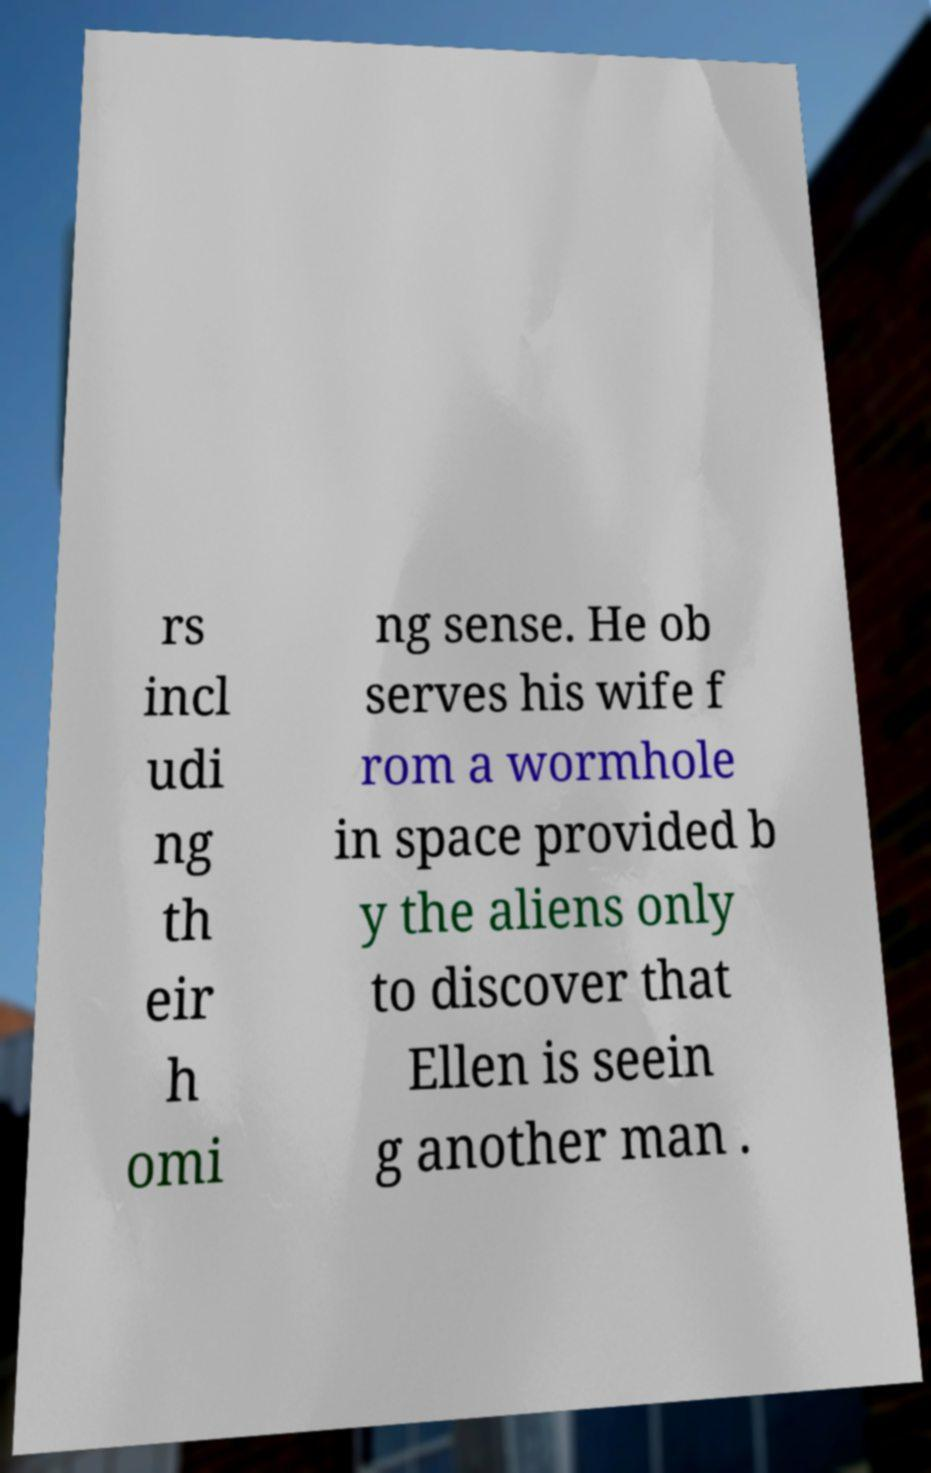I need the written content from this picture converted into text. Can you do that? rs incl udi ng th eir h omi ng sense. He ob serves his wife f rom a wormhole in space provided b y the aliens only to discover that Ellen is seein g another man . 